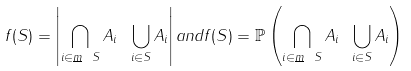<formula> <loc_0><loc_0><loc_500><loc_500>f ( S ) = \left | \bigcap _ { i \in { \underline { m } } \ S } A _ { i } \ \bigcup _ { i \in S } A _ { i } \right | { a n d } f ( S ) = \mathbb { P } \left ( \bigcap _ { i \in { \underline { m } } \ S } A _ { i } \ \bigcup _ { i \in S } A _ { i } \right )</formula> 